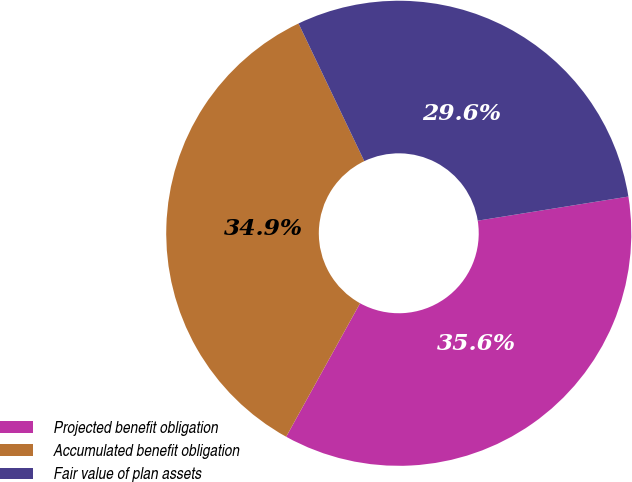<chart> <loc_0><loc_0><loc_500><loc_500><pie_chart><fcel>Projected benefit obligation<fcel>Accumulated benefit obligation<fcel>Fair value of plan assets<nl><fcel>35.57%<fcel>34.86%<fcel>29.57%<nl></chart> 